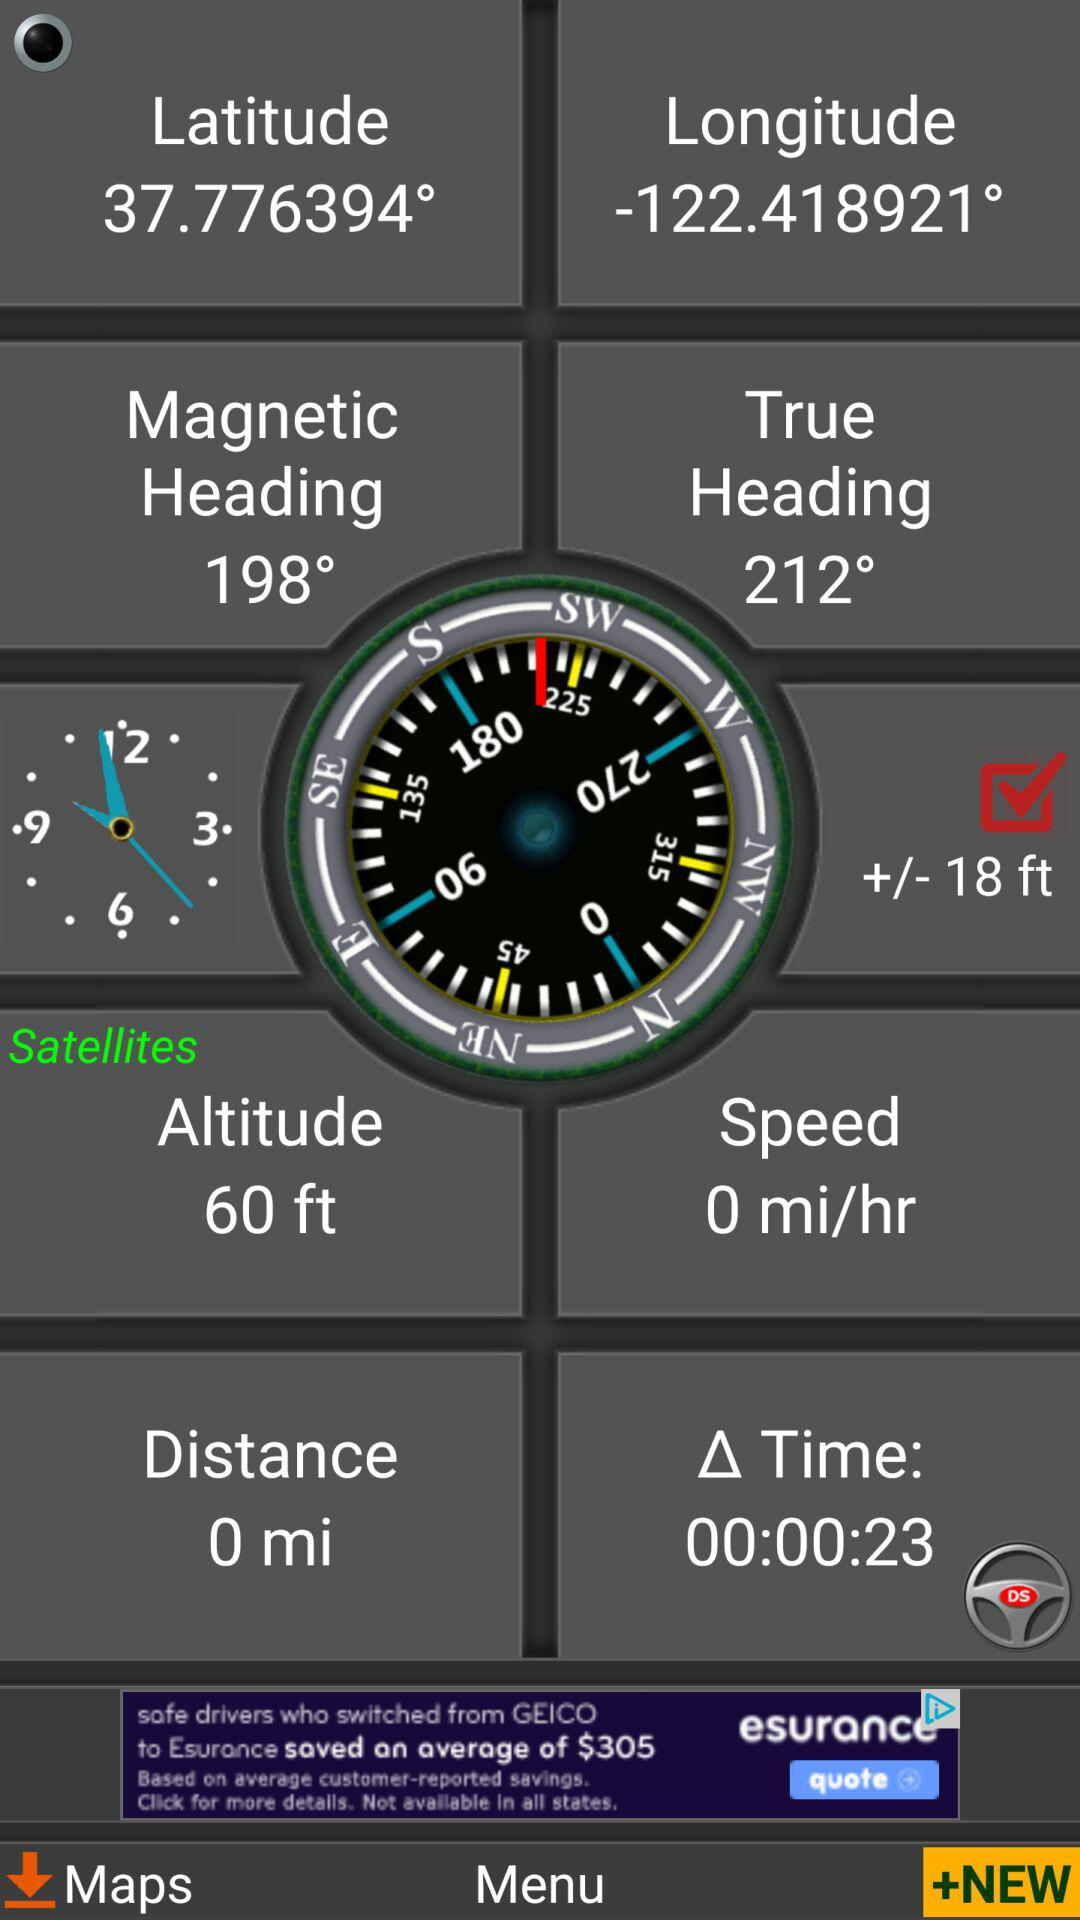What is the magnetic heading? The magnetic heading is 198°. 